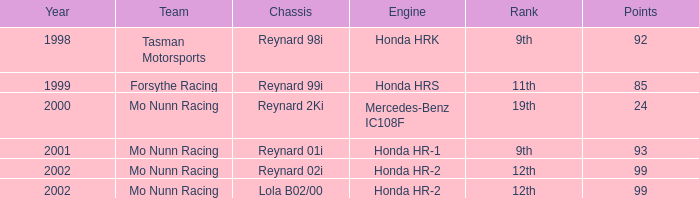Would you be able to parse every entry in this table? {'header': ['Year', 'Team', 'Chassis', 'Engine', 'Rank', 'Points'], 'rows': [['1998', 'Tasman Motorsports', 'Reynard 98i', 'Honda HRK', '9th', '92'], ['1999', 'Forsythe Racing', 'Reynard 99i', 'Honda HRS', '11th', '85'], ['2000', 'Mo Nunn Racing', 'Reynard 2Ki', 'Mercedes-Benz IC108F', '19th', '24'], ['2001', 'Mo Nunn Racing', 'Reynard 01i', 'Honda HR-1', '9th', '93'], ['2002', 'Mo Nunn Racing', 'Reynard 02i', 'Honda HR-2', '12th', '99'], ['2002', 'Mo Nunn Racing', 'Lola B02/00', 'Honda HR-2', '12th', '99']]} What is the standing of the reynard 2ki chassis before 2002? 19th. 